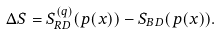Convert formula to latex. <formula><loc_0><loc_0><loc_500><loc_500>\Delta S = S ^ { ( q ) } _ { R D } ( p ( x ) ) - S _ { B D } ( p ( x ) ) .</formula> 